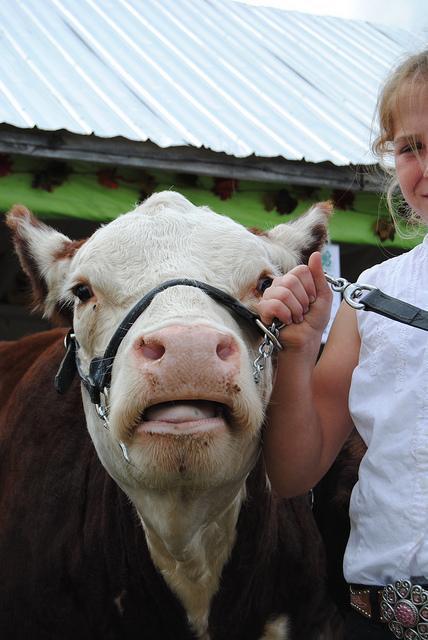Does the description: "The cow is behind the person." accurately reflect the image?
Answer yes or no. No. Does the image validate the caption "The person is behind the cow."?
Answer yes or no. No. Does the image validate the caption "The cow is at the right side of the person."?
Answer yes or no. Yes. 